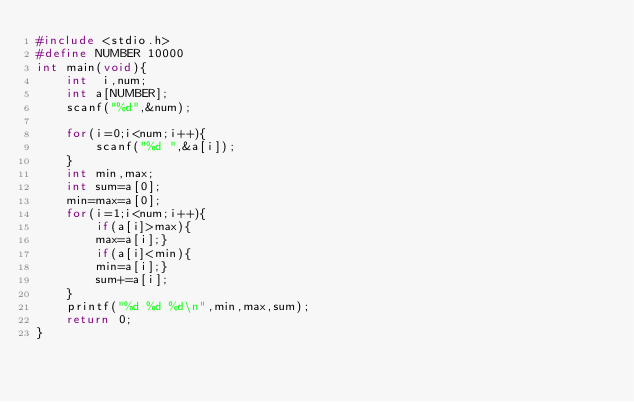Convert code to text. <code><loc_0><loc_0><loc_500><loc_500><_C_>#include <stdio.h>
#define NUMBER 10000
int main(void){
    int  i,num;
    int a[NUMBER];
    scanf("%d",&num);
    
    for(i=0;i<num;i++){
        scanf("%d ",&a[i]);
    }
    int min,max;
    int sum=a[0];
    min=max=a[0];
    for(i=1;i<num;i++){
        if(a[i]>max){
        max=a[i];}
        if(a[i]<min){
        min=a[i];}
        sum+=a[i];
    }
    printf("%d %d %d\n",min,max,sum);
    return 0;
}
</code> 